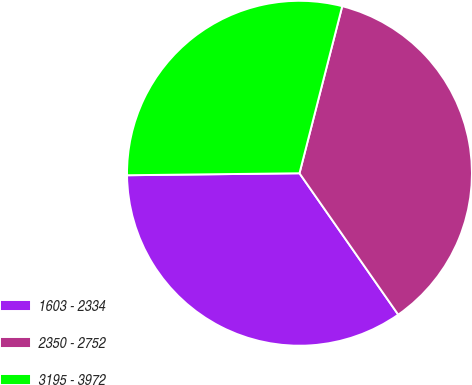Convert chart to OTSL. <chart><loc_0><loc_0><loc_500><loc_500><pie_chart><fcel>1603 - 2334<fcel>2350 - 2752<fcel>3195 - 3972<nl><fcel>34.52%<fcel>36.31%<fcel>29.17%<nl></chart> 